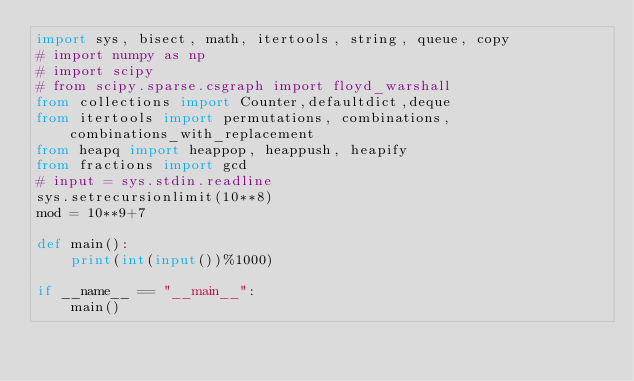<code> <loc_0><loc_0><loc_500><loc_500><_Python_>import sys, bisect, math, itertools, string, queue, copy
# import numpy as np
# import scipy
# from scipy.sparse.csgraph import floyd_warshall
from collections import Counter,defaultdict,deque
from itertools import permutations, combinations, combinations_with_replacement
from heapq import heappop, heappush, heapify
from fractions import gcd
# input = sys.stdin.readline
sys.setrecursionlimit(10**8)
mod = 10**9+7

def main():
    print(int(input())%1000)
    
if __name__ == "__main__":
    main()</code> 